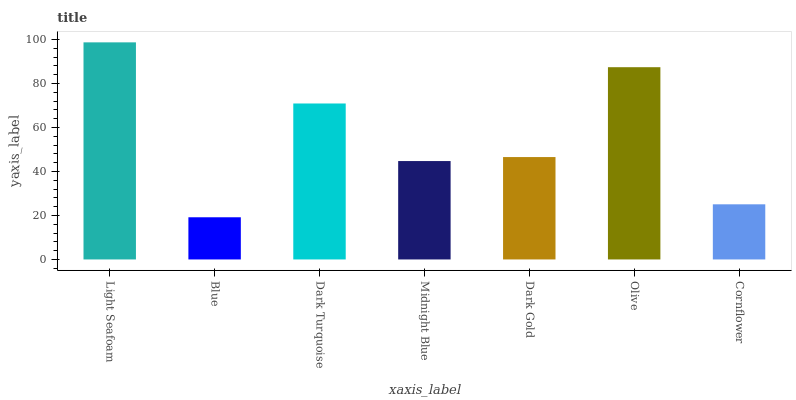Is Blue the minimum?
Answer yes or no. Yes. Is Light Seafoam the maximum?
Answer yes or no. Yes. Is Dark Turquoise the minimum?
Answer yes or no. No. Is Dark Turquoise the maximum?
Answer yes or no. No. Is Dark Turquoise greater than Blue?
Answer yes or no. Yes. Is Blue less than Dark Turquoise?
Answer yes or no. Yes. Is Blue greater than Dark Turquoise?
Answer yes or no. No. Is Dark Turquoise less than Blue?
Answer yes or no. No. Is Dark Gold the high median?
Answer yes or no. Yes. Is Dark Gold the low median?
Answer yes or no. Yes. Is Midnight Blue the high median?
Answer yes or no. No. Is Dark Turquoise the low median?
Answer yes or no. No. 